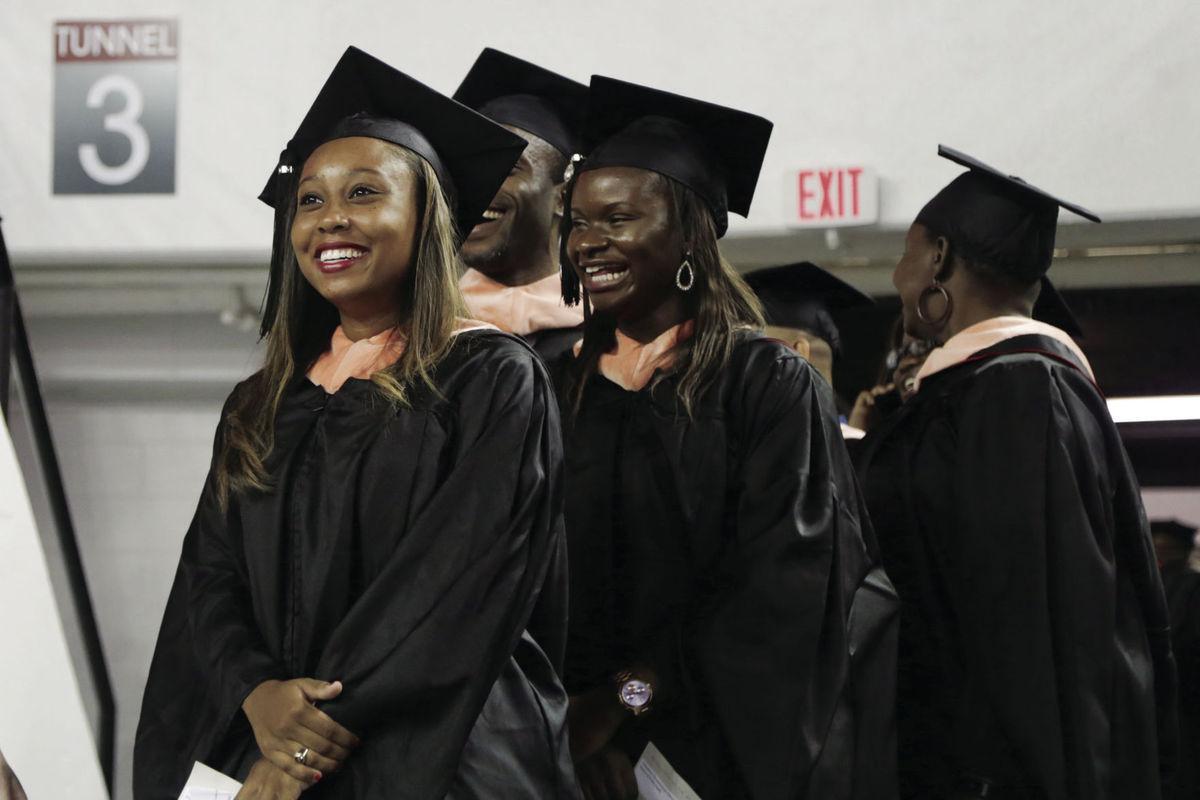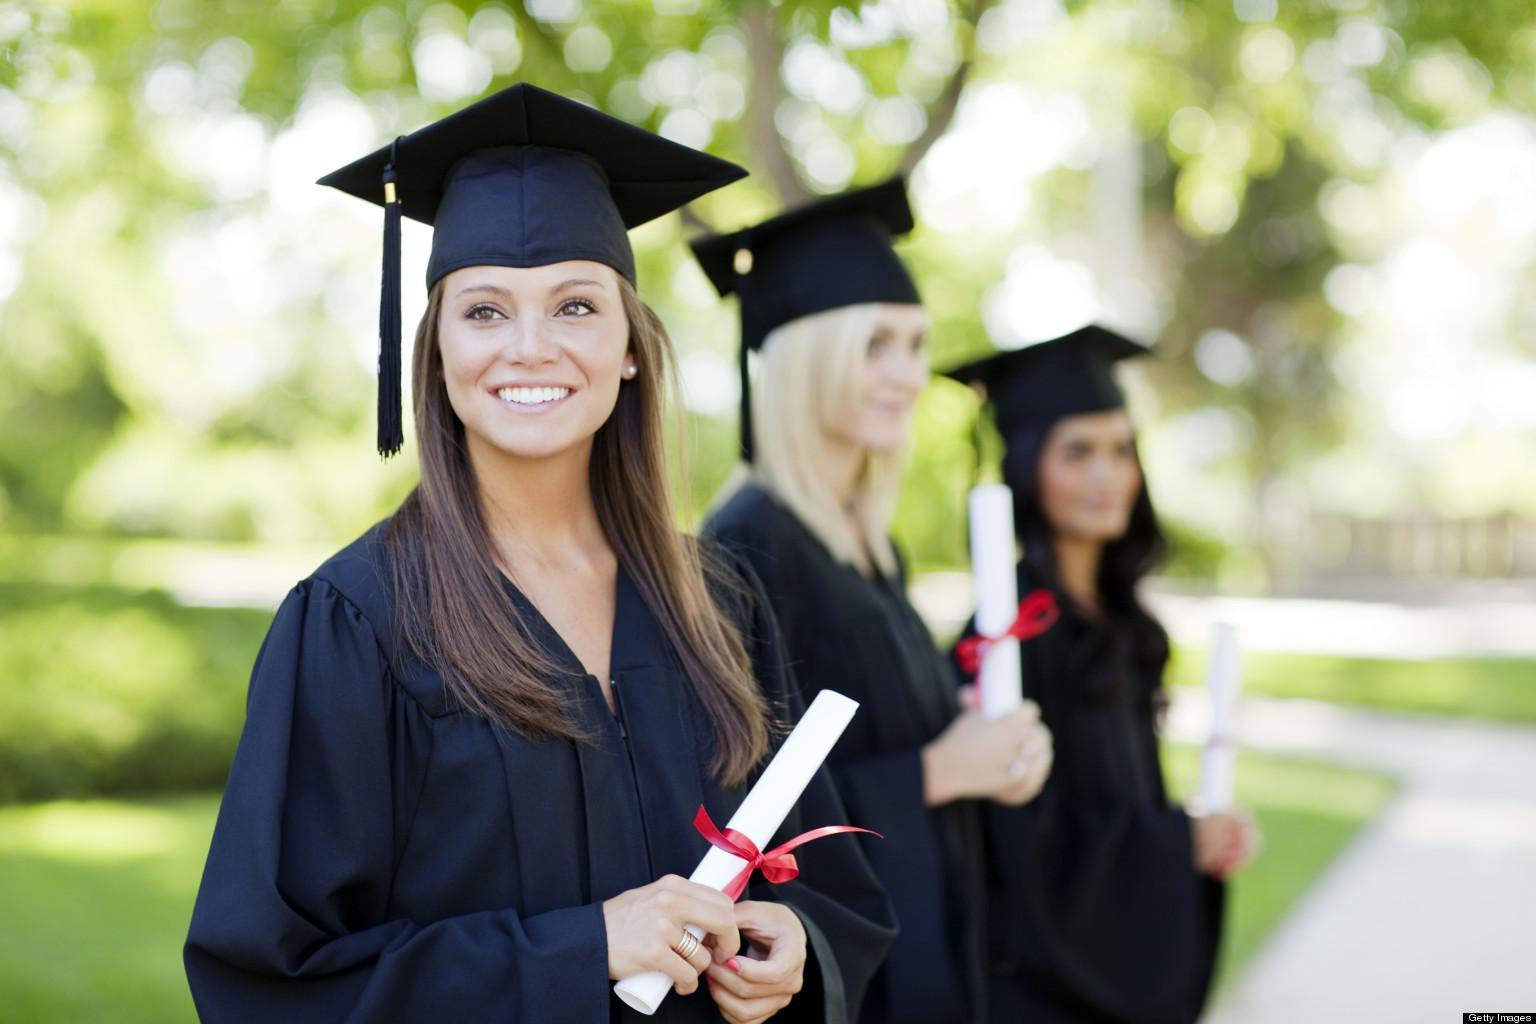The first image is the image on the left, the second image is the image on the right. Assess this claim about the two images: "There are more people posing in their caps and gowns in the image on the right.". Correct or not? Answer yes or no. No. The first image is the image on the left, the second image is the image on the right. Assess this claim about the two images: "All graduates wear dark caps and robes, and the left image shows a smiling black graduate alone in the foreground.". Correct or not? Answer yes or no. No. 